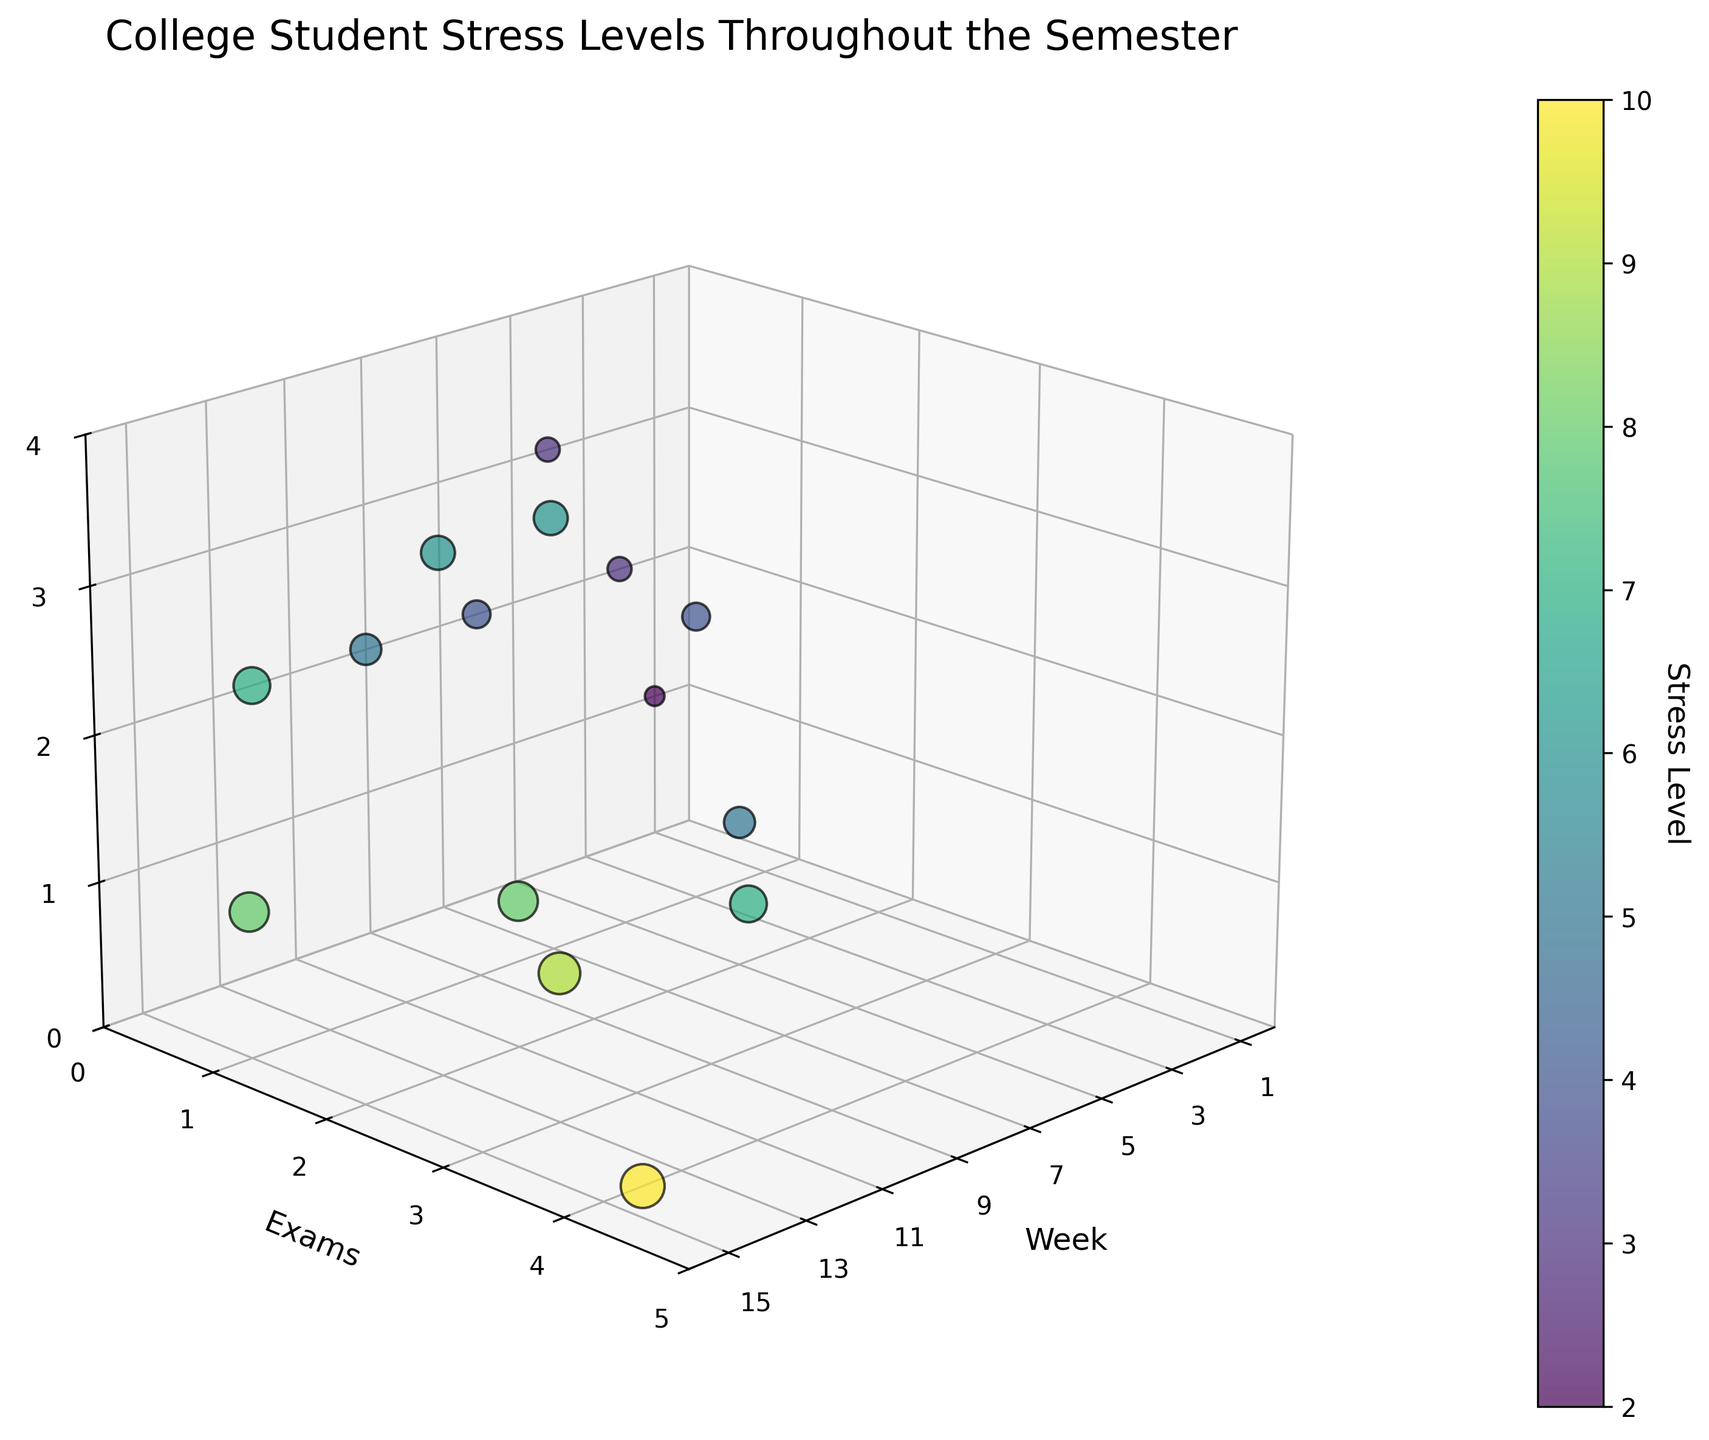What is the title of the plot? The plot's title is often displayed prominently to describe the overall subject of the visualization. Look at the top of the figure.
Answer: College Student Stress Levels Throughout the Semester How many weeks are displayed on the x-axis? The x-axis labels usually show the range or specific points being measured. Check the x-axis labels to count the weeks.
Answer: 15 How many exams are there during Week 5? Identify the point on Week 5 and note the value labeled on the 'Exams' axis.
Answer: 2 Which week shows the highest stress level? Look for the data point with the largest circle and check its position on the 'Week' axis and its color intensity.
Answer: Week 14 What is the range of extracurricular activities throughout the semester? Use the z-axis to observe the lowest and highest number of extracurricular activities recorded across all weeks.
Answer: 0 to 3 Which weeks have no exams scheduled? Check the 'Exams' axis for points that align with zero. Then confirm their corresponding weeks on the x-axis.
Answer: Weeks 1, 2, 4, 6, 9, and 12 During which week is the stress level at 7? Focus on the color indicating stress level of 7, then determine the corresponding week on the x-axis.
Answer: Weeks 8 and 12 On average, how many exams occur per week? Sum the number of exams across all weeks and divide by 15 (total weeks). (0+0+1+0+2+0+1+3+0+1+2+0+3+4+1)/15 = 18/15
Answer: 1.2 How does the stress level change as exams increase? Analyze the data points for trends in stress levels as the number of exams rises on the 'Exams' axis. Generally, higher exam counts correlate with increased stress, indicated by larger data points and more intense colors.
Answer: Stress increases Which has a stronger correlation to stress levels: exams or extracurriculars? Compare the distribution and sizes/color intensities of points across the 'Exams' and 'Extracurriculars' axes. Determine which axis shows a more direct relationship with stress levels.
Answer: Exams show a stronger correlation In which week is the discrepancy between the number of exams and extracurricular activities the largest? Find the week where the difference between the values on the 'Exams' and 'Extracurriculars' axes is greatest.
Answer: Week 14 